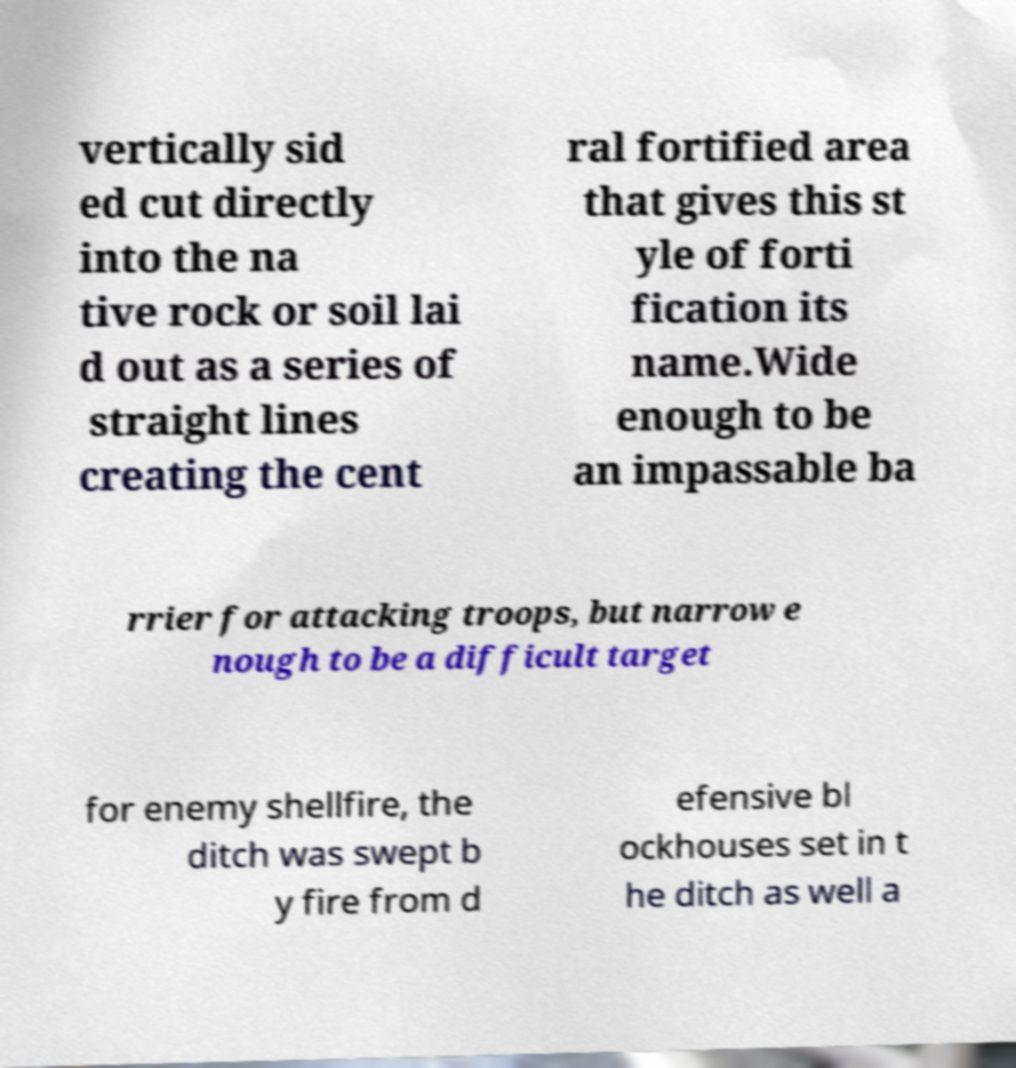Could you assist in decoding the text presented in this image and type it out clearly? vertically sid ed cut directly into the na tive rock or soil lai d out as a series of straight lines creating the cent ral fortified area that gives this st yle of forti fication its name.Wide enough to be an impassable ba rrier for attacking troops, but narrow e nough to be a difficult target for enemy shellfire, the ditch was swept b y fire from d efensive bl ockhouses set in t he ditch as well a 